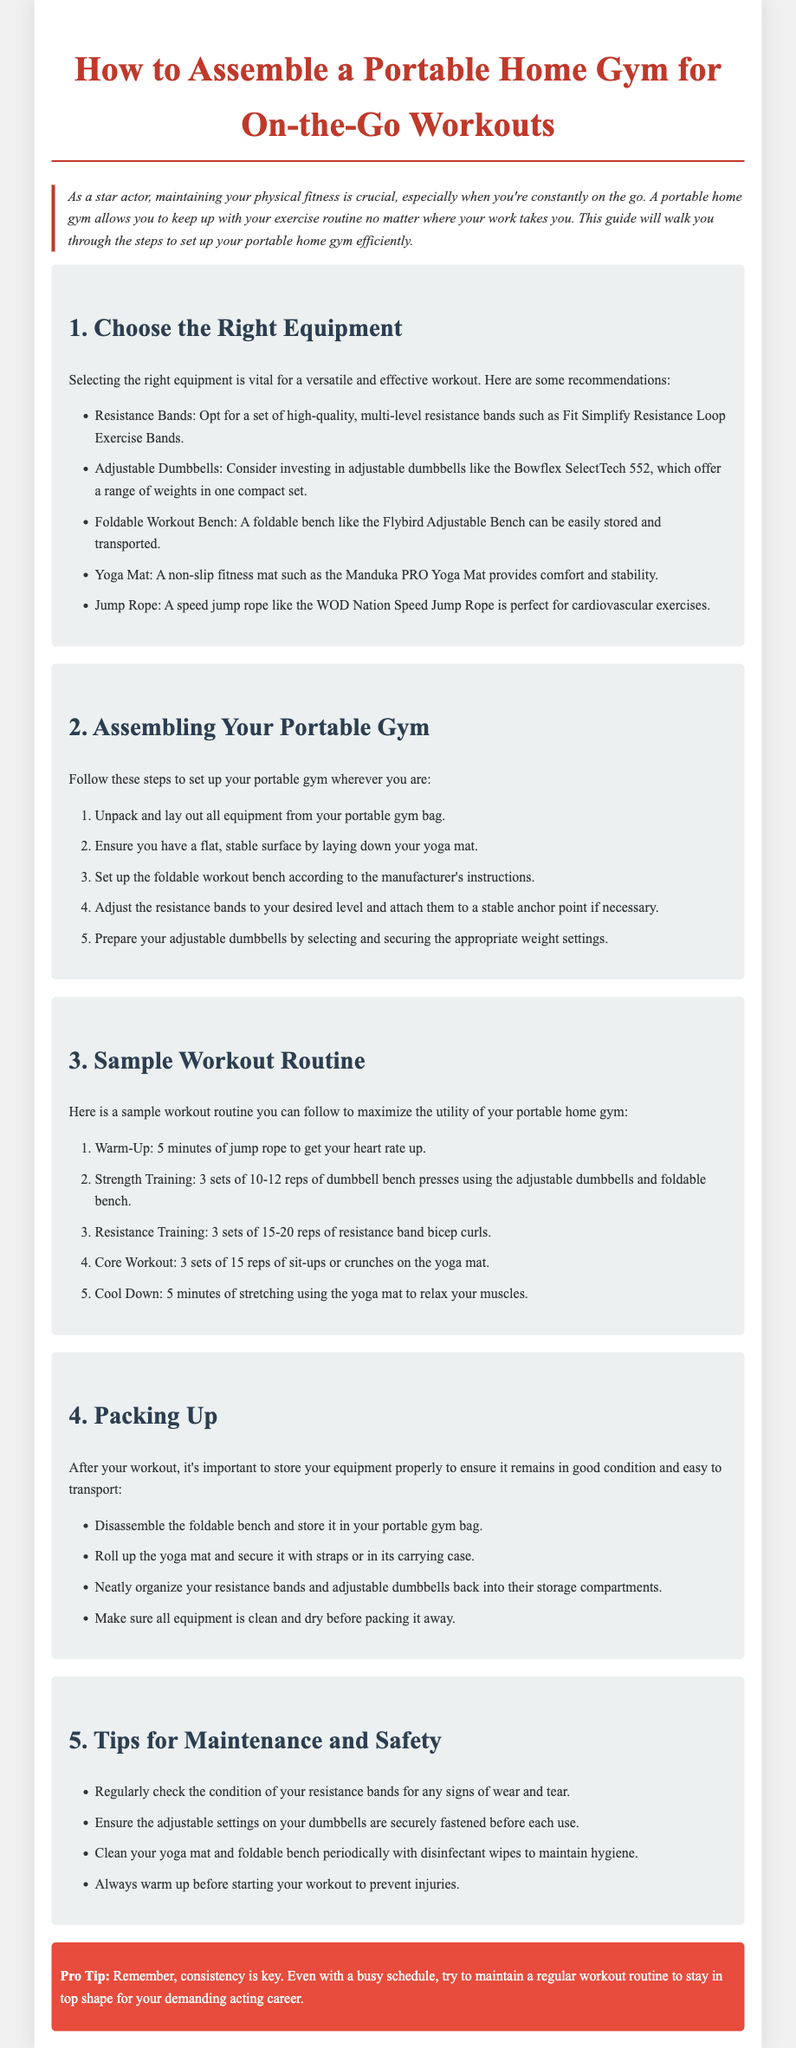What are the recommended resistance bands? The document mentions high-quality, multi-level resistance bands such as Fit Simplify Resistance Loop Exercise Bands.
Answer: Fit Simplify Resistance Loop Exercise Bands How many sets of dumbbell bench presses are suggested? The assembly instructions indicate performing 3 sets of 10-12 reps of dumbbell bench presses.
Answer: 3 sets of 10-12 reps What type of mat is recommended for workouts? The guide suggests a non-slip fitness mat such as the Manduka PRO Yoga Mat for comfort and stability.
Answer: Manduka PRO Yoga Mat What is the first step to set up your portable gym? The instructions begin with unpacking and laying out all equipment from your portable gym bag.
Answer: Unpack and lay out all equipment How should the foldable bench be stored after use? The document specifies to disassemble the foldable bench and store it in your portable gym bag.
Answer: Store it in your portable gym bag What should be checked regularly for maintenance? The document states that you should regularly check the condition of your resistance bands for any signs of wear and tear.
Answer: Condition of resistance bands Which piece of equipment is mentioned for cardiovascular exercises? The guide includes a speed jump rope like the WOD Nation Speed Jump Rope for cardiovascular exercises.
Answer: WOD Nation Speed Jump Rope 